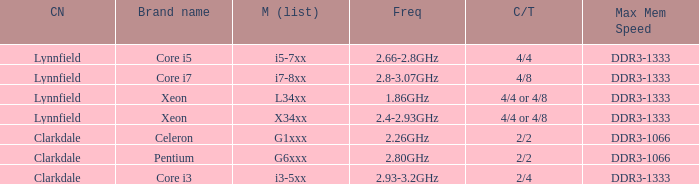What brand is model G6xxx? Pentium. 